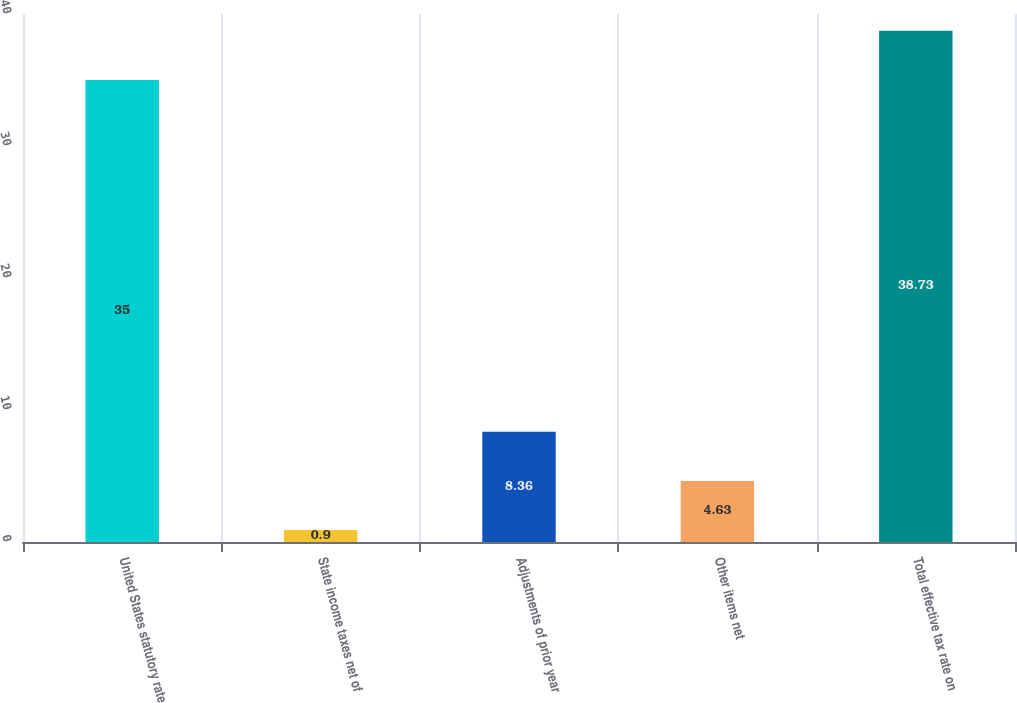Convert chart to OTSL. <chart><loc_0><loc_0><loc_500><loc_500><bar_chart><fcel>United States statutory rate<fcel>State income taxes net of<fcel>Adjustments of prior year<fcel>Other items net<fcel>Total effective tax rate on<nl><fcel>35<fcel>0.9<fcel>8.36<fcel>4.63<fcel>38.73<nl></chart> 